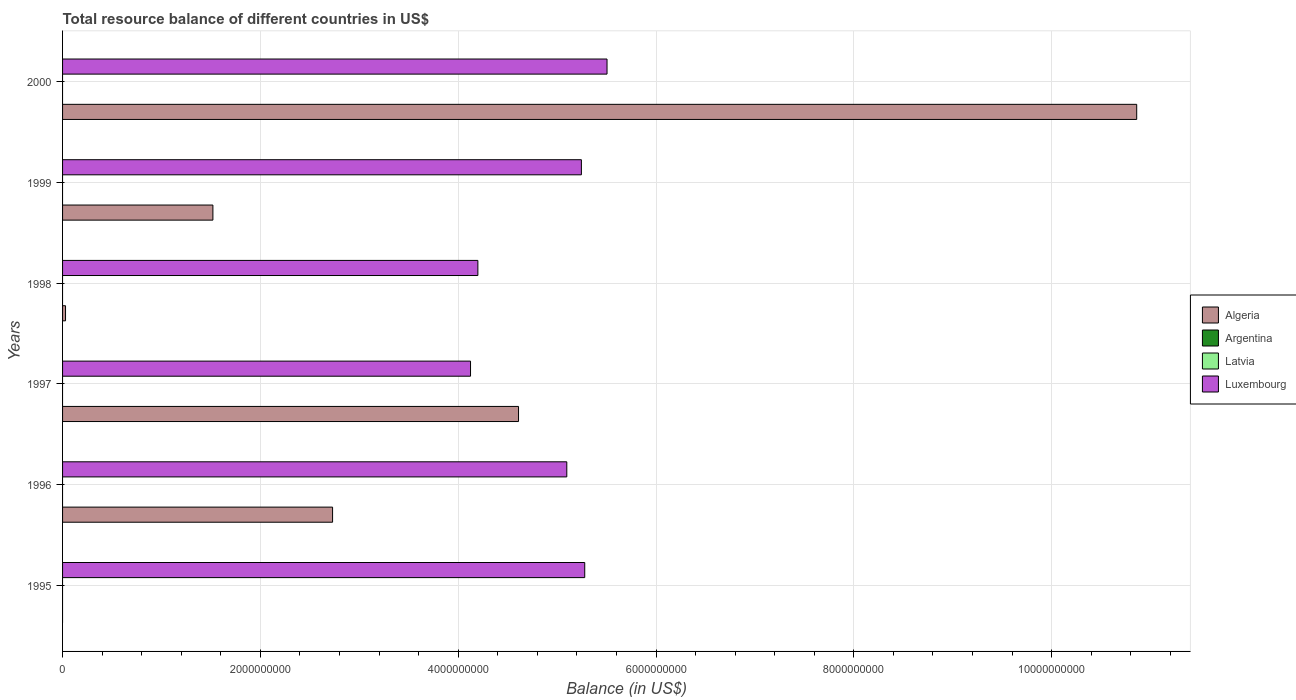Are the number of bars on each tick of the Y-axis equal?
Ensure brevity in your answer.  No. How many bars are there on the 2nd tick from the bottom?
Your response must be concise. 2. What is the label of the 3rd group of bars from the top?
Your response must be concise. 1998. What is the total resource balance in Algeria in 1999?
Offer a terse response. 1.52e+09. Across all years, what is the maximum total resource balance in Luxembourg?
Offer a terse response. 5.50e+09. In which year was the total resource balance in Luxembourg maximum?
Make the answer very short. 2000. What is the total total resource balance in Luxembourg in the graph?
Provide a succinct answer. 2.95e+1. What is the difference between the total resource balance in Algeria in 1998 and that in 2000?
Your answer should be very brief. -1.08e+1. What is the difference between the total resource balance in Algeria in 1996 and the total resource balance in Luxembourg in 1995?
Your response must be concise. -2.55e+09. In the year 1996, what is the difference between the total resource balance in Luxembourg and total resource balance in Algeria?
Your response must be concise. 2.37e+09. In how many years, is the total resource balance in Algeria greater than 8800000000 US$?
Give a very brief answer. 1. What is the ratio of the total resource balance in Luxembourg in 1996 to that in 1998?
Offer a very short reply. 1.21. Is the total resource balance in Algeria in 1996 less than that in 2000?
Keep it short and to the point. Yes. What is the difference between the highest and the second highest total resource balance in Algeria?
Keep it short and to the point. 6.25e+09. What is the difference between the highest and the lowest total resource balance in Algeria?
Keep it short and to the point. 1.09e+1. In how many years, is the total resource balance in Algeria greater than the average total resource balance in Algeria taken over all years?
Provide a succinct answer. 2. Is the sum of the total resource balance in Luxembourg in 1996 and 2000 greater than the maximum total resource balance in Latvia across all years?
Make the answer very short. Yes. How many bars are there?
Your response must be concise. 11. Are all the bars in the graph horizontal?
Offer a terse response. Yes. How many years are there in the graph?
Your answer should be compact. 6. What is the difference between two consecutive major ticks on the X-axis?
Offer a terse response. 2.00e+09. Are the values on the major ticks of X-axis written in scientific E-notation?
Give a very brief answer. No. Does the graph contain grids?
Offer a very short reply. Yes. How many legend labels are there?
Provide a short and direct response. 4. What is the title of the graph?
Ensure brevity in your answer.  Total resource balance of different countries in US$. What is the label or title of the X-axis?
Your answer should be very brief. Balance (in US$). What is the Balance (in US$) of Algeria in 1995?
Ensure brevity in your answer.  0. What is the Balance (in US$) in Latvia in 1995?
Ensure brevity in your answer.  0. What is the Balance (in US$) in Luxembourg in 1995?
Offer a very short reply. 5.28e+09. What is the Balance (in US$) of Algeria in 1996?
Offer a very short reply. 2.73e+09. What is the Balance (in US$) of Latvia in 1996?
Keep it short and to the point. 0. What is the Balance (in US$) of Luxembourg in 1996?
Your response must be concise. 5.10e+09. What is the Balance (in US$) of Algeria in 1997?
Provide a succinct answer. 4.61e+09. What is the Balance (in US$) in Argentina in 1997?
Ensure brevity in your answer.  0. What is the Balance (in US$) in Latvia in 1997?
Provide a succinct answer. 0. What is the Balance (in US$) in Luxembourg in 1997?
Your response must be concise. 4.12e+09. What is the Balance (in US$) in Algeria in 1998?
Provide a short and direct response. 3.00e+07. What is the Balance (in US$) in Luxembourg in 1998?
Provide a short and direct response. 4.20e+09. What is the Balance (in US$) in Algeria in 1999?
Offer a very short reply. 1.52e+09. What is the Balance (in US$) in Argentina in 1999?
Ensure brevity in your answer.  0. What is the Balance (in US$) of Latvia in 1999?
Offer a terse response. 0. What is the Balance (in US$) of Luxembourg in 1999?
Your response must be concise. 5.25e+09. What is the Balance (in US$) in Algeria in 2000?
Offer a terse response. 1.09e+1. What is the Balance (in US$) in Latvia in 2000?
Keep it short and to the point. 0. What is the Balance (in US$) in Luxembourg in 2000?
Your response must be concise. 5.50e+09. Across all years, what is the maximum Balance (in US$) of Algeria?
Offer a terse response. 1.09e+1. Across all years, what is the maximum Balance (in US$) of Luxembourg?
Your answer should be compact. 5.50e+09. Across all years, what is the minimum Balance (in US$) of Luxembourg?
Offer a terse response. 4.12e+09. What is the total Balance (in US$) in Algeria in the graph?
Give a very brief answer. 1.98e+1. What is the total Balance (in US$) in Argentina in the graph?
Your answer should be very brief. 0. What is the total Balance (in US$) in Luxembourg in the graph?
Provide a short and direct response. 2.95e+1. What is the difference between the Balance (in US$) of Luxembourg in 1995 and that in 1996?
Give a very brief answer. 1.81e+08. What is the difference between the Balance (in US$) in Luxembourg in 1995 and that in 1997?
Provide a succinct answer. 1.15e+09. What is the difference between the Balance (in US$) of Luxembourg in 1995 and that in 1998?
Keep it short and to the point. 1.08e+09. What is the difference between the Balance (in US$) of Luxembourg in 1995 and that in 1999?
Your answer should be compact. 3.37e+07. What is the difference between the Balance (in US$) of Luxembourg in 1995 and that in 2000?
Keep it short and to the point. -2.25e+08. What is the difference between the Balance (in US$) of Algeria in 1996 and that in 1997?
Your answer should be very brief. -1.88e+09. What is the difference between the Balance (in US$) in Luxembourg in 1996 and that in 1997?
Keep it short and to the point. 9.73e+08. What is the difference between the Balance (in US$) of Algeria in 1996 and that in 1998?
Give a very brief answer. 2.70e+09. What is the difference between the Balance (in US$) of Luxembourg in 1996 and that in 1998?
Provide a succinct answer. 8.99e+08. What is the difference between the Balance (in US$) of Algeria in 1996 and that in 1999?
Provide a short and direct response. 1.21e+09. What is the difference between the Balance (in US$) of Luxembourg in 1996 and that in 1999?
Offer a very short reply. -1.48e+08. What is the difference between the Balance (in US$) of Algeria in 1996 and that in 2000?
Provide a short and direct response. -8.13e+09. What is the difference between the Balance (in US$) of Luxembourg in 1996 and that in 2000?
Offer a terse response. -4.07e+08. What is the difference between the Balance (in US$) in Algeria in 1997 and that in 1998?
Your response must be concise. 4.58e+09. What is the difference between the Balance (in US$) in Luxembourg in 1997 and that in 1998?
Your answer should be very brief. -7.42e+07. What is the difference between the Balance (in US$) of Algeria in 1997 and that in 1999?
Give a very brief answer. 3.09e+09. What is the difference between the Balance (in US$) in Luxembourg in 1997 and that in 1999?
Make the answer very short. -1.12e+09. What is the difference between the Balance (in US$) of Algeria in 1997 and that in 2000?
Provide a short and direct response. -6.25e+09. What is the difference between the Balance (in US$) in Luxembourg in 1997 and that in 2000?
Provide a short and direct response. -1.38e+09. What is the difference between the Balance (in US$) of Algeria in 1998 and that in 1999?
Your answer should be very brief. -1.49e+09. What is the difference between the Balance (in US$) of Luxembourg in 1998 and that in 1999?
Offer a terse response. -1.05e+09. What is the difference between the Balance (in US$) in Algeria in 1998 and that in 2000?
Provide a short and direct response. -1.08e+1. What is the difference between the Balance (in US$) in Luxembourg in 1998 and that in 2000?
Ensure brevity in your answer.  -1.31e+09. What is the difference between the Balance (in US$) in Algeria in 1999 and that in 2000?
Provide a short and direct response. -9.34e+09. What is the difference between the Balance (in US$) of Luxembourg in 1999 and that in 2000?
Offer a terse response. -2.59e+08. What is the difference between the Balance (in US$) in Algeria in 1996 and the Balance (in US$) in Luxembourg in 1997?
Provide a short and direct response. -1.39e+09. What is the difference between the Balance (in US$) in Algeria in 1996 and the Balance (in US$) in Luxembourg in 1998?
Provide a succinct answer. -1.47e+09. What is the difference between the Balance (in US$) of Algeria in 1996 and the Balance (in US$) of Luxembourg in 1999?
Your answer should be compact. -2.52e+09. What is the difference between the Balance (in US$) in Algeria in 1996 and the Balance (in US$) in Luxembourg in 2000?
Offer a very short reply. -2.77e+09. What is the difference between the Balance (in US$) in Algeria in 1997 and the Balance (in US$) in Luxembourg in 1998?
Your answer should be very brief. 4.11e+08. What is the difference between the Balance (in US$) in Algeria in 1997 and the Balance (in US$) in Luxembourg in 1999?
Provide a succinct answer. -6.36e+08. What is the difference between the Balance (in US$) of Algeria in 1997 and the Balance (in US$) of Luxembourg in 2000?
Offer a very short reply. -8.95e+08. What is the difference between the Balance (in US$) of Algeria in 1998 and the Balance (in US$) of Luxembourg in 1999?
Ensure brevity in your answer.  -5.22e+09. What is the difference between the Balance (in US$) of Algeria in 1998 and the Balance (in US$) of Luxembourg in 2000?
Keep it short and to the point. -5.47e+09. What is the difference between the Balance (in US$) of Algeria in 1999 and the Balance (in US$) of Luxembourg in 2000?
Offer a very short reply. -3.98e+09. What is the average Balance (in US$) in Algeria per year?
Your response must be concise. 3.29e+09. What is the average Balance (in US$) of Latvia per year?
Your answer should be very brief. 0. What is the average Balance (in US$) of Luxembourg per year?
Your response must be concise. 4.91e+09. In the year 1996, what is the difference between the Balance (in US$) of Algeria and Balance (in US$) of Luxembourg?
Offer a very short reply. -2.37e+09. In the year 1997, what is the difference between the Balance (in US$) in Algeria and Balance (in US$) in Luxembourg?
Offer a very short reply. 4.85e+08. In the year 1998, what is the difference between the Balance (in US$) of Algeria and Balance (in US$) of Luxembourg?
Make the answer very short. -4.17e+09. In the year 1999, what is the difference between the Balance (in US$) in Algeria and Balance (in US$) in Luxembourg?
Make the answer very short. -3.73e+09. In the year 2000, what is the difference between the Balance (in US$) of Algeria and Balance (in US$) of Luxembourg?
Give a very brief answer. 5.36e+09. What is the ratio of the Balance (in US$) of Luxembourg in 1995 to that in 1996?
Offer a terse response. 1.04. What is the ratio of the Balance (in US$) in Luxembourg in 1995 to that in 1997?
Give a very brief answer. 1.28. What is the ratio of the Balance (in US$) of Luxembourg in 1995 to that in 1998?
Your response must be concise. 1.26. What is the ratio of the Balance (in US$) in Luxembourg in 1995 to that in 1999?
Provide a short and direct response. 1.01. What is the ratio of the Balance (in US$) in Luxembourg in 1995 to that in 2000?
Offer a terse response. 0.96. What is the ratio of the Balance (in US$) in Algeria in 1996 to that in 1997?
Keep it short and to the point. 0.59. What is the ratio of the Balance (in US$) in Luxembourg in 1996 to that in 1997?
Your answer should be very brief. 1.24. What is the ratio of the Balance (in US$) in Algeria in 1996 to that in 1998?
Your answer should be very brief. 91. What is the ratio of the Balance (in US$) in Luxembourg in 1996 to that in 1998?
Ensure brevity in your answer.  1.21. What is the ratio of the Balance (in US$) in Algeria in 1996 to that in 1999?
Ensure brevity in your answer.  1.8. What is the ratio of the Balance (in US$) in Luxembourg in 1996 to that in 1999?
Your response must be concise. 0.97. What is the ratio of the Balance (in US$) in Algeria in 1996 to that in 2000?
Ensure brevity in your answer.  0.25. What is the ratio of the Balance (in US$) in Luxembourg in 1996 to that in 2000?
Your answer should be very brief. 0.93. What is the ratio of the Balance (in US$) of Algeria in 1997 to that in 1998?
Your answer should be very brief. 153.66. What is the ratio of the Balance (in US$) in Luxembourg in 1997 to that in 1998?
Offer a very short reply. 0.98. What is the ratio of the Balance (in US$) in Algeria in 1997 to that in 1999?
Give a very brief answer. 3.03. What is the ratio of the Balance (in US$) in Luxembourg in 1997 to that in 1999?
Your answer should be compact. 0.79. What is the ratio of the Balance (in US$) in Algeria in 1997 to that in 2000?
Your response must be concise. 0.42. What is the ratio of the Balance (in US$) of Luxembourg in 1997 to that in 2000?
Ensure brevity in your answer.  0.75. What is the ratio of the Balance (in US$) of Algeria in 1998 to that in 1999?
Your answer should be very brief. 0.02. What is the ratio of the Balance (in US$) of Luxembourg in 1998 to that in 1999?
Offer a terse response. 0.8. What is the ratio of the Balance (in US$) of Algeria in 1998 to that in 2000?
Offer a terse response. 0. What is the ratio of the Balance (in US$) of Luxembourg in 1998 to that in 2000?
Your response must be concise. 0.76. What is the ratio of the Balance (in US$) of Algeria in 1999 to that in 2000?
Your answer should be very brief. 0.14. What is the ratio of the Balance (in US$) in Luxembourg in 1999 to that in 2000?
Keep it short and to the point. 0.95. What is the difference between the highest and the second highest Balance (in US$) of Algeria?
Make the answer very short. 6.25e+09. What is the difference between the highest and the second highest Balance (in US$) of Luxembourg?
Make the answer very short. 2.25e+08. What is the difference between the highest and the lowest Balance (in US$) in Algeria?
Keep it short and to the point. 1.09e+1. What is the difference between the highest and the lowest Balance (in US$) in Luxembourg?
Give a very brief answer. 1.38e+09. 